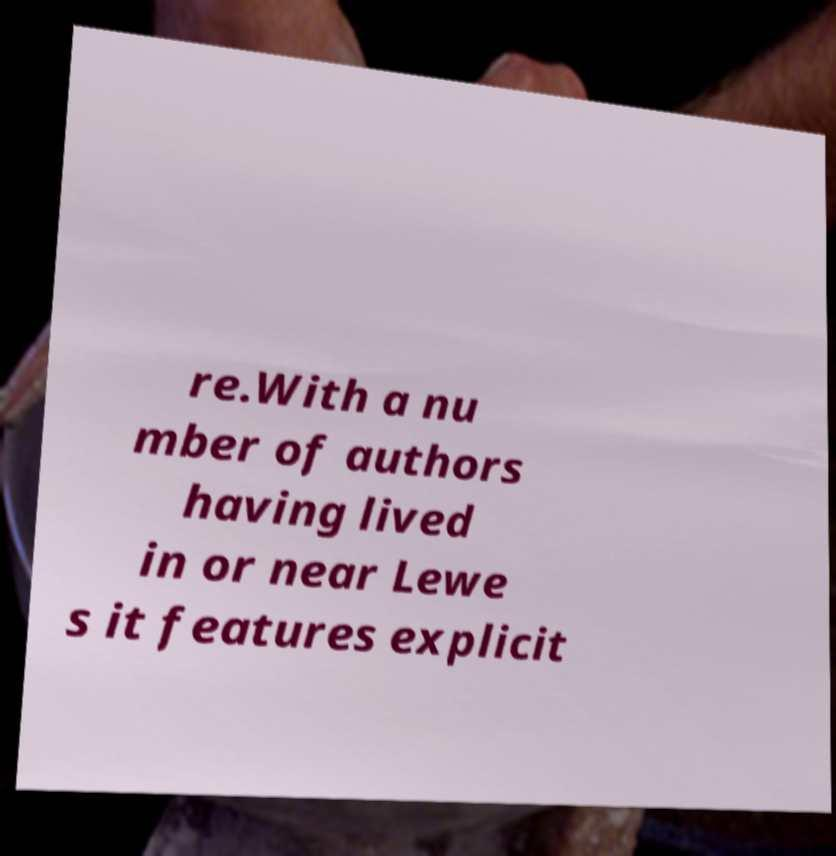There's text embedded in this image that I need extracted. Can you transcribe it verbatim? re.With a nu mber of authors having lived in or near Lewe s it features explicit 